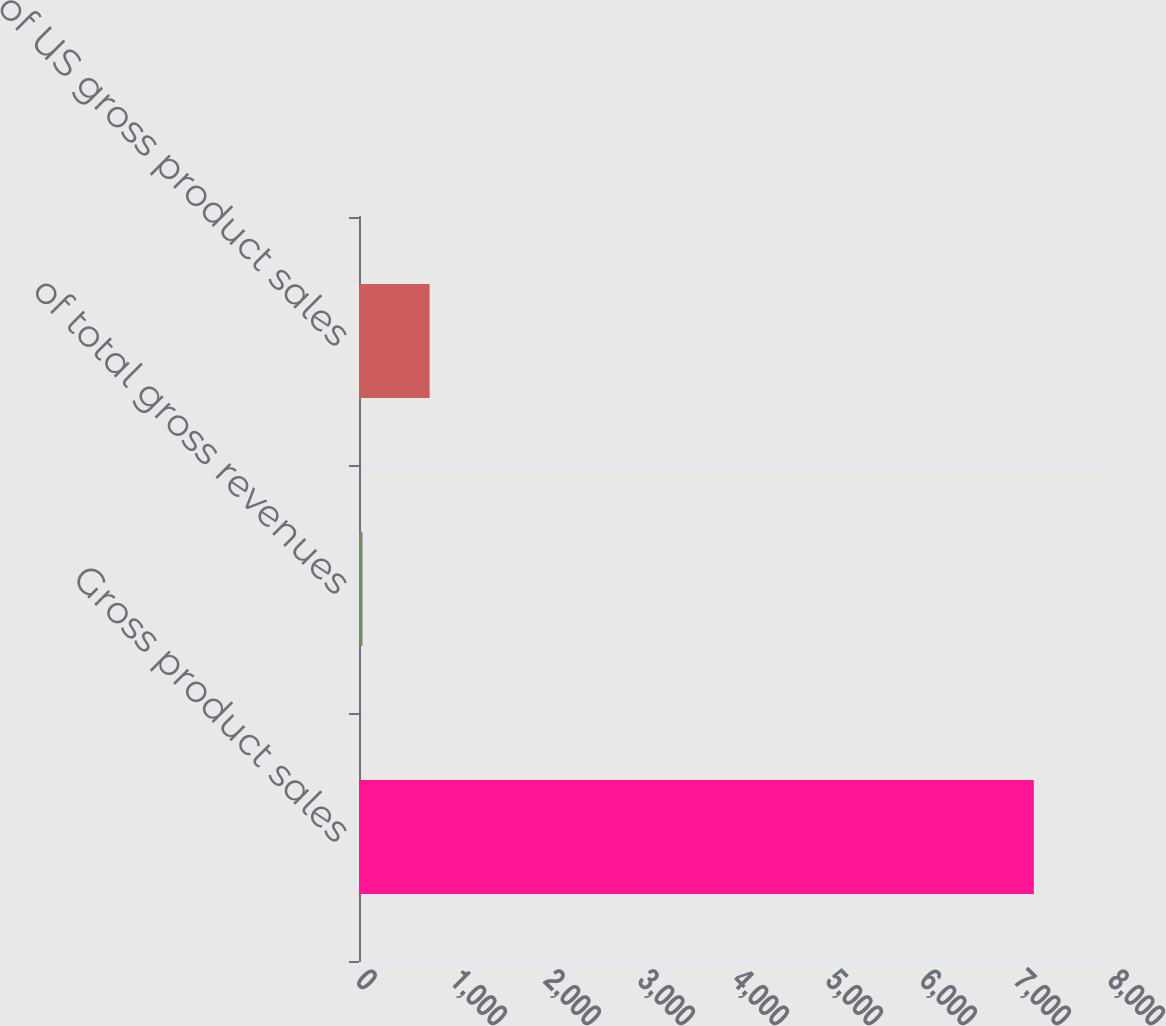<chart> <loc_0><loc_0><loc_500><loc_500><bar_chart><fcel>Gross product sales<fcel>of total gross revenues<fcel>of US gross product sales<nl><fcel>7179<fcel>37<fcel>751.2<nl></chart> 